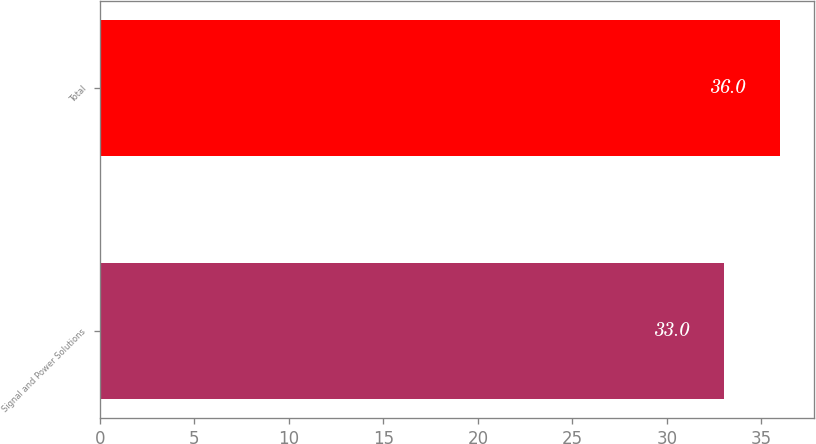<chart> <loc_0><loc_0><loc_500><loc_500><bar_chart><fcel>Signal and Power Solutions<fcel>Total<nl><fcel>33<fcel>36<nl></chart> 